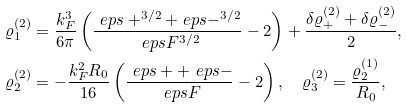Convert formula to latex. <formula><loc_0><loc_0><loc_500><loc_500>\varrho ^ { ( 2 ) } _ { 1 } & = \frac { k _ { F } ^ { 3 } } { 6 \pi } \left ( \frac { \ e p s + ^ { 3 / 2 } + \ e p s - ^ { 3 / 2 } } { \ e p s { F } ^ { 3 / 2 } } - 2 \right ) + \frac { \delta \varrho ^ { ( 2 ) } _ { + } + \delta \varrho ^ { ( 2 ) } _ { - } } { 2 } , \\ \varrho ^ { ( 2 ) } _ { 2 } & = - \frac { k _ { F } ^ { 2 } R _ { 0 } } { 1 6 } \left ( \frac { \ e p s + + \ e p s - } { \ e p s { F } } - 2 \right ) , \quad \varrho ^ { ( 2 ) } _ { 3 } = \frac { \varrho ^ { ( 1 ) } _ { 2 } } { R _ { 0 } } ,</formula> 